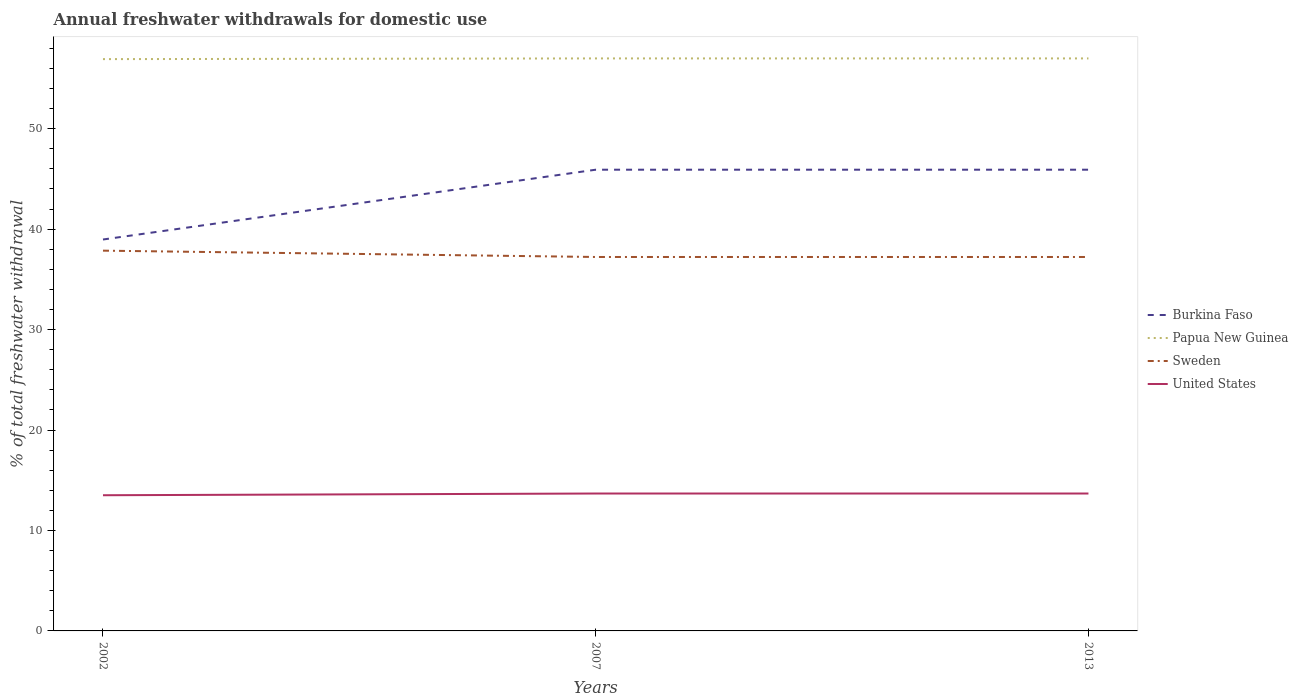Does the line corresponding to Sweden intersect with the line corresponding to Burkina Faso?
Your answer should be compact. No. Across all years, what is the maximum total annual withdrawals from freshwater in Burkina Faso?
Your answer should be compact. 38.97. What is the total total annual withdrawals from freshwater in Burkina Faso in the graph?
Your answer should be very brief. -6.95. What is the difference between the highest and the second highest total annual withdrawals from freshwater in Sweden?
Your answer should be very brief. 0.63. How many lines are there?
Make the answer very short. 4. Does the graph contain grids?
Your answer should be very brief. No. Where does the legend appear in the graph?
Your answer should be very brief. Center right. How many legend labels are there?
Keep it short and to the point. 4. What is the title of the graph?
Give a very brief answer. Annual freshwater withdrawals for domestic use. What is the label or title of the X-axis?
Your answer should be very brief. Years. What is the label or title of the Y-axis?
Provide a short and direct response. % of total freshwater withdrawal. What is the % of total freshwater withdrawal of Burkina Faso in 2002?
Give a very brief answer. 38.97. What is the % of total freshwater withdrawal of Papua New Guinea in 2002?
Your answer should be compact. 56.93. What is the % of total freshwater withdrawal of Sweden in 2002?
Ensure brevity in your answer.  37.86. What is the % of total freshwater withdrawal of United States in 2002?
Keep it short and to the point. 13.51. What is the % of total freshwater withdrawal in Burkina Faso in 2007?
Provide a short and direct response. 45.92. What is the % of total freshwater withdrawal in Papua New Guinea in 2007?
Make the answer very short. 57. What is the % of total freshwater withdrawal of Sweden in 2007?
Keep it short and to the point. 37.23. What is the % of total freshwater withdrawal of United States in 2007?
Give a very brief answer. 13.68. What is the % of total freshwater withdrawal in Burkina Faso in 2013?
Your answer should be very brief. 45.92. What is the % of total freshwater withdrawal of Papua New Guinea in 2013?
Keep it short and to the point. 57. What is the % of total freshwater withdrawal of Sweden in 2013?
Give a very brief answer. 37.23. What is the % of total freshwater withdrawal of United States in 2013?
Give a very brief answer. 13.68. Across all years, what is the maximum % of total freshwater withdrawal in Burkina Faso?
Offer a very short reply. 45.92. Across all years, what is the maximum % of total freshwater withdrawal in Sweden?
Make the answer very short. 37.86. Across all years, what is the maximum % of total freshwater withdrawal of United States?
Ensure brevity in your answer.  13.68. Across all years, what is the minimum % of total freshwater withdrawal of Burkina Faso?
Keep it short and to the point. 38.97. Across all years, what is the minimum % of total freshwater withdrawal in Papua New Guinea?
Provide a succinct answer. 56.93. Across all years, what is the minimum % of total freshwater withdrawal of Sweden?
Provide a succinct answer. 37.23. Across all years, what is the minimum % of total freshwater withdrawal of United States?
Provide a short and direct response. 13.51. What is the total % of total freshwater withdrawal in Burkina Faso in the graph?
Your response must be concise. 130.81. What is the total % of total freshwater withdrawal in Papua New Guinea in the graph?
Keep it short and to the point. 170.93. What is the total % of total freshwater withdrawal of Sweden in the graph?
Offer a terse response. 112.32. What is the total % of total freshwater withdrawal of United States in the graph?
Make the answer very short. 40.87. What is the difference between the % of total freshwater withdrawal in Burkina Faso in 2002 and that in 2007?
Provide a succinct answer. -6.95. What is the difference between the % of total freshwater withdrawal in Papua New Guinea in 2002 and that in 2007?
Provide a succinct answer. -0.07. What is the difference between the % of total freshwater withdrawal of Sweden in 2002 and that in 2007?
Ensure brevity in your answer.  0.63. What is the difference between the % of total freshwater withdrawal of United States in 2002 and that in 2007?
Make the answer very short. -0.17. What is the difference between the % of total freshwater withdrawal of Burkina Faso in 2002 and that in 2013?
Your answer should be very brief. -6.95. What is the difference between the % of total freshwater withdrawal of Papua New Guinea in 2002 and that in 2013?
Offer a terse response. -0.07. What is the difference between the % of total freshwater withdrawal of Sweden in 2002 and that in 2013?
Offer a very short reply. 0.63. What is the difference between the % of total freshwater withdrawal in United States in 2002 and that in 2013?
Offer a terse response. -0.17. What is the difference between the % of total freshwater withdrawal in Sweden in 2007 and that in 2013?
Provide a short and direct response. 0. What is the difference between the % of total freshwater withdrawal of United States in 2007 and that in 2013?
Keep it short and to the point. 0. What is the difference between the % of total freshwater withdrawal of Burkina Faso in 2002 and the % of total freshwater withdrawal of Papua New Guinea in 2007?
Offer a very short reply. -18.03. What is the difference between the % of total freshwater withdrawal in Burkina Faso in 2002 and the % of total freshwater withdrawal in Sweden in 2007?
Your response must be concise. 1.74. What is the difference between the % of total freshwater withdrawal of Burkina Faso in 2002 and the % of total freshwater withdrawal of United States in 2007?
Provide a succinct answer. 25.29. What is the difference between the % of total freshwater withdrawal in Papua New Guinea in 2002 and the % of total freshwater withdrawal in United States in 2007?
Give a very brief answer. 43.25. What is the difference between the % of total freshwater withdrawal of Sweden in 2002 and the % of total freshwater withdrawal of United States in 2007?
Provide a succinct answer. 24.18. What is the difference between the % of total freshwater withdrawal in Burkina Faso in 2002 and the % of total freshwater withdrawal in Papua New Guinea in 2013?
Your answer should be very brief. -18.03. What is the difference between the % of total freshwater withdrawal in Burkina Faso in 2002 and the % of total freshwater withdrawal in Sweden in 2013?
Make the answer very short. 1.74. What is the difference between the % of total freshwater withdrawal of Burkina Faso in 2002 and the % of total freshwater withdrawal of United States in 2013?
Offer a terse response. 25.29. What is the difference between the % of total freshwater withdrawal of Papua New Guinea in 2002 and the % of total freshwater withdrawal of United States in 2013?
Ensure brevity in your answer.  43.25. What is the difference between the % of total freshwater withdrawal in Sweden in 2002 and the % of total freshwater withdrawal in United States in 2013?
Your answer should be very brief. 24.18. What is the difference between the % of total freshwater withdrawal of Burkina Faso in 2007 and the % of total freshwater withdrawal of Papua New Guinea in 2013?
Make the answer very short. -11.08. What is the difference between the % of total freshwater withdrawal of Burkina Faso in 2007 and the % of total freshwater withdrawal of Sweden in 2013?
Your answer should be very brief. 8.69. What is the difference between the % of total freshwater withdrawal in Burkina Faso in 2007 and the % of total freshwater withdrawal in United States in 2013?
Your response must be concise. 32.24. What is the difference between the % of total freshwater withdrawal in Papua New Guinea in 2007 and the % of total freshwater withdrawal in Sweden in 2013?
Your response must be concise. 19.77. What is the difference between the % of total freshwater withdrawal of Papua New Guinea in 2007 and the % of total freshwater withdrawal of United States in 2013?
Make the answer very short. 43.32. What is the difference between the % of total freshwater withdrawal in Sweden in 2007 and the % of total freshwater withdrawal in United States in 2013?
Give a very brief answer. 23.55. What is the average % of total freshwater withdrawal of Burkina Faso per year?
Make the answer very short. 43.6. What is the average % of total freshwater withdrawal in Papua New Guinea per year?
Your answer should be compact. 56.98. What is the average % of total freshwater withdrawal of Sweden per year?
Offer a very short reply. 37.44. What is the average % of total freshwater withdrawal in United States per year?
Your answer should be compact. 13.62. In the year 2002, what is the difference between the % of total freshwater withdrawal of Burkina Faso and % of total freshwater withdrawal of Papua New Guinea?
Keep it short and to the point. -17.96. In the year 2002, what is the difference between the % of total freshwater withdrawal of Burkina Faso and % of total freshwater withdrawal of Sweden?
Provide a short and direct response. 1.11. In the year 2002, what is the difference between the % of total freshwater withdrawal in Burkina Faso and % of total freshwater withdrawal in United States?
Make the answer very short. 25.46. In the year 2002, what is the difference between the % of total freshwater withdrawal of Papua New Guinea and % of total freshwater withdrawal of Sweden?
Make the answer very short. 19.07. In the year 2002, what is the difference between the % of total freshwater withdrawal in Papua New Guinea and % of total freshwater withdrawal in United States?
Ensure brevity in your answer.  43.42. In the year 2002, what is the difference between the % of total freshwater withdrawal of Sweden and % of total freshwater withdrawal of United States?
Ensure brevity in your answer.  24.35. In the year 2007, what is the difference between the % of total freshwater withdrawal of Burkina Faso and % of total freshwater withdrawal of Papua New Guinea?
Give a very brief answer. -11.08. In the year 2007, what is the difference between the % of total freshwater withdrawal of Burkina Faso and % of total freshwater withdrawal of Sweden?
Give a very brief answer. 8.69. In the year 2007, what is the difference between the % of total freshwater withdrawal in Burkina Faso and % of total freshwater withdrawal in United States?
Ensure brevity in your answer.  32.24. In the year 2007, what is the difference between the % of total freshwater withdrawal in Papua New Guinea and % of total freshwater withdrawal in Sweden?
Your answer should be very brief. 19.77. In the year 2007, what is the difference between the % of total freshwater withdrawal in Papua New Guinea and % of total freshwater withdrawal in United States?
Offer a terse response. 43.32. In the year 2007, what is the difference between the % of total freshwater withdrawal in Sweden and % of total freshwater withdrawal in United States?
Offer a very short reply. 23.55. In the year 2013, what is the difference between the % of total freshwater withdrawal of Burkina Faso and % of total freshwater withdrawal of Papua New Guinea?
Your answer should be compact. -11.08. In the year 2013, what is the difference between the % of total freshwater withdrawal of Burkina Faso and % of total freshwater withdrawal of Sweden?
Provide a short and direct response. 8.69. In the year 2013, what is the difference between the % of total freshwater withdrawal in Burkina Faso and % of total freshwater withdrawal in United States?
Your response must be concise. 32.24. In the year 2013, what is the difference between the % of total freshwater withdrawal of Papua New Guinea and % of total freshwater withdrawal of Sweden?
Offer a terse response. 19.77. In the year 2013, what is the difference between the % of total freshwater withdrawal of Papua New Guinea and % of total freshwater withdrawal of United States?
Provide a succinct answer. 43.32. In the year 2013, what is the difference between the % of total freshwater withdrawal of Sweden and % of total freshwater withdrawal of United States?
Keep it short and to the point. 23.55. What is the ratio of the % of total freshwater withdrawal of Burkina Faso in 2002 to that in 2007?
Your response must be concise. 0.85. What is the ratio of the % of total freshwater withdrawal in Papua New Guinea in 2002 to that in 2007?
Provide a succinct answer. 1. What is the ratio of the % of total freshwater withdrawal of Sweden in 2002 to that in 2007?
Ensure brevity in your answer.  1.02. What is the ratio of the % of total freshwater withdrawal of United States in 2002 to that in 2007?
Give a very brief answer. 0.99. What is the ratio of the % of total freshwater withdrawal of Burkina Faso in 2002 to that in 2013?
Your answer should be compact. 0.85. What is the ratio of the % of total freshwater withdrawal of Papua New Guinea in 2002 to that in 2013?
Give a very brief answer. 1. What is the ratio of the % of total freshwater withdrawal of Sweden in 2002 to that in 2013?
Offer a very short reply. 1.02. What is the ratio of the % of total freshwater withdrawal of United States in 2002 to that in 2013?
Provide a succinct answer. 0.99. What is the ratio of the % of total freshwater withdrawal of Burkina Faso in 2007 to that in 2013?
Offer a terse response. 1. What is the ratio of the % of total freshwater withdrawal of Papua New Guinea in 2007 to that in 2013?
Provide a short and direct response. 1. What is the ratio of the % of total freshwater withdrawal in United States in 2007 to that in 2013?
Ensure brevity in your answer.  1. What is the difference between the highest and the second highest % of total freshwater withdrawal in Sweden?
Offer a terse response. 0.63. What is the difference between the highest and the lowest % of total freshwater withdrawal in Burkina Faso?
Provide a succinct answer. 6.95. What is the difference between the highest and the lowest % of total freshwater withdrawal of Papua New Guinea?
Your answer should be compact. 0.07. What is the difference between the highest and the lowest % of total freshwater withdrawal of Sweden?
Offer a terse response. 0.63. What is the difference between the highest and the lowest % of total freshwater withdrawal in United States?
Provide a succinct answer. 0.17. 